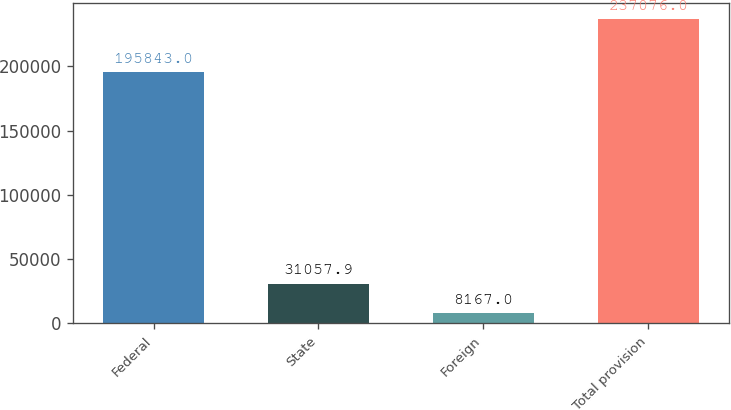Convert chart. <chart><loc_0><loc_0><loc_500><loc_500><bar_chart><fcel>Federal<fcel>State<fcel>Foreign<fcel>Total provision<nl><fcel>195843<fcel>31057.9<fcel>8167<fcel>237076<nl></chart> 